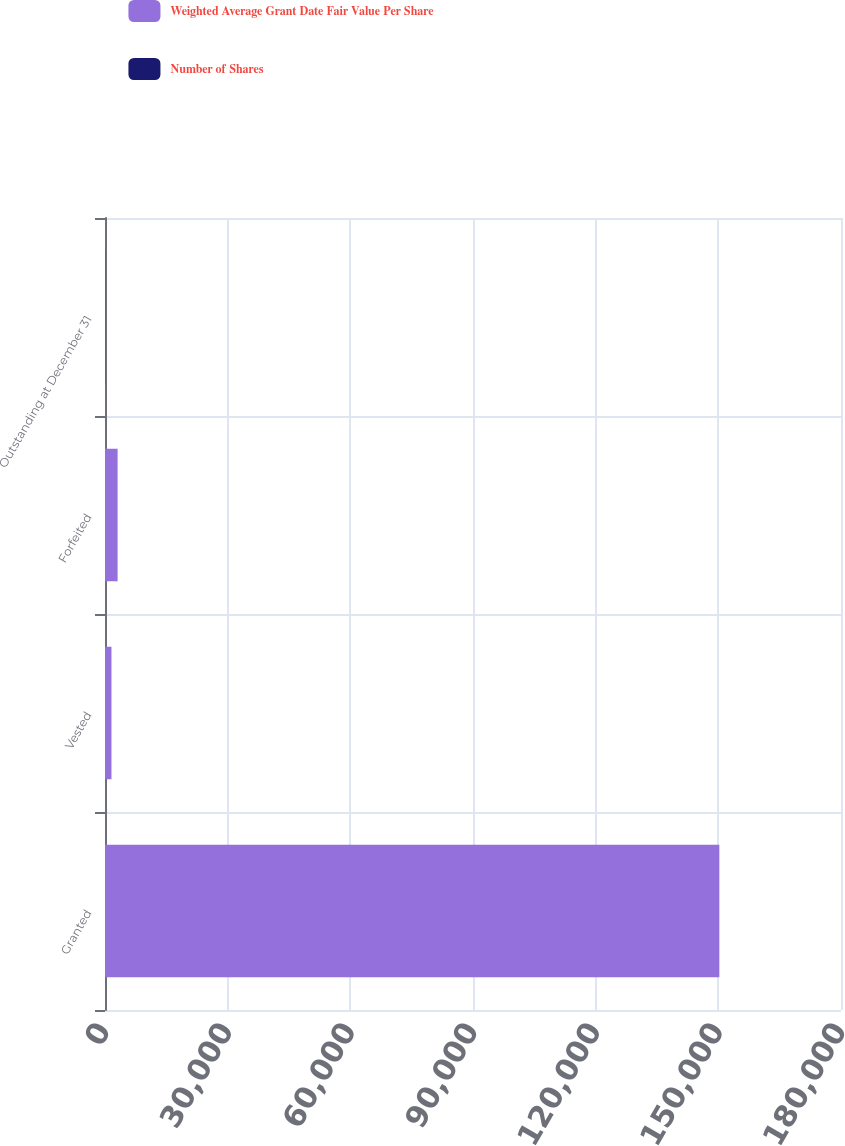Convert chart. <chart><loc_0><loc_0><loc_500><loc_500><stacked_bar_chart><ecel><fcel>Granted<fcel>Vested<fcel>Forfeited<fcel>Outstanding at December 31<nl><fcel>Weighted Average Grant Date Fair Value Per Share<fcel>150187<fcel>1523<fcel>3030<fcel>42.78<nl><fcel>Number of Shares<fcel>33.27<fcel>33.3<fcel>33.3<fcel>42.78<nl></chart> 